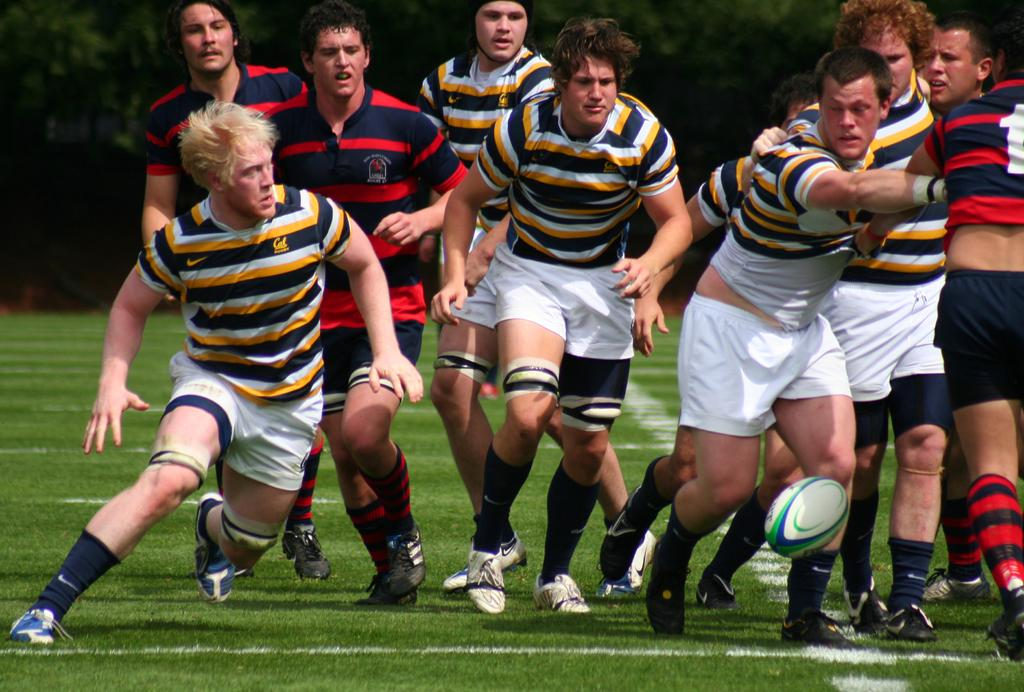What can be seen in the image? There are players in the image. What are the players wearing? The players are wearing yellow and red t-shirts. What is visible in the background of the image? There are trees and grass visible in the background of the image. What book is the deer reading in the image? There is no book or deer present in the image; it features players wearing yellow and red t-shirts with trees and grass in the background. 